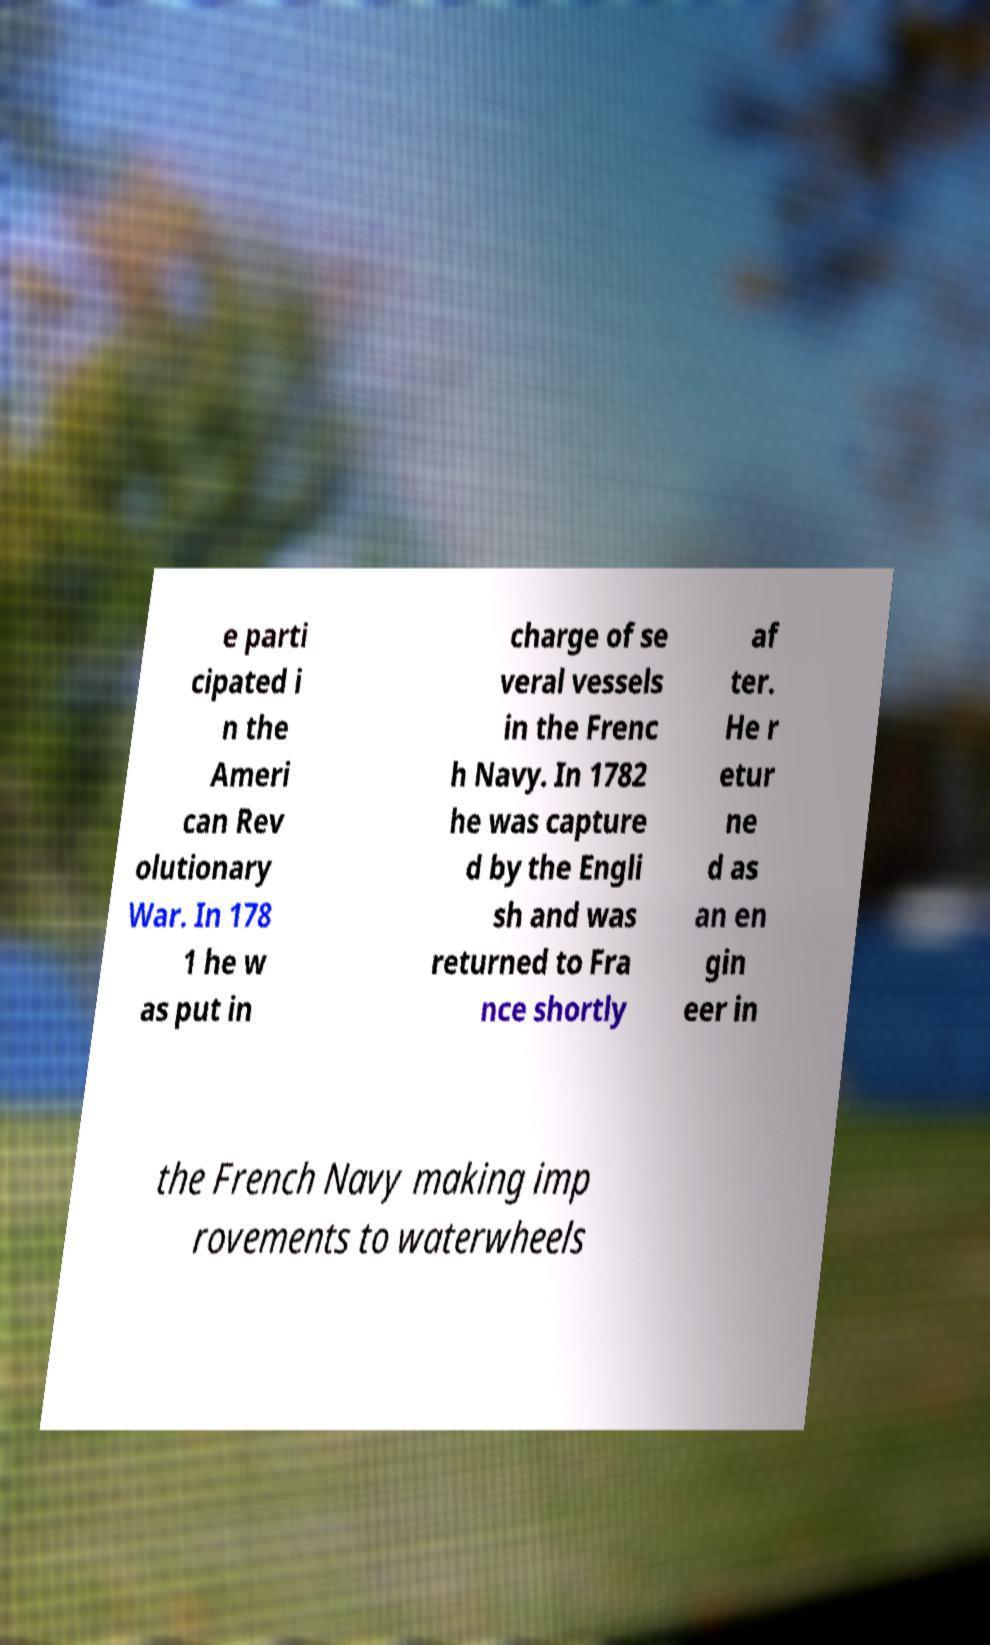For documentation purposes, I need the text within this image transcribed. Could you provide that? e parti cipated i n the Ameri can Rev olutionary War. In 178 1 he w as put in charge of se veral vessels in the Frenc h Navy. In 1782 he was capture d by the Engli sh and was returned to Fra nce shortly af ter. He r etur ne d as an en gin eer in the French Navy making imp rovements to waterwheels 